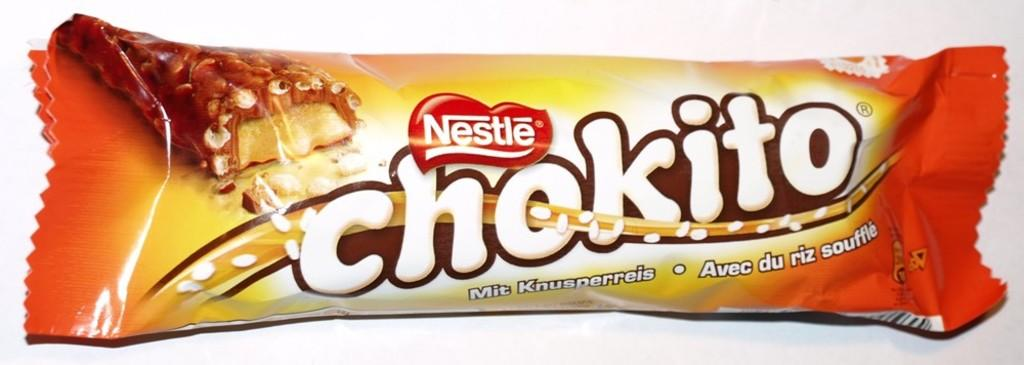What is the main subject of the image? The main subject of the image is a chocolate packet. Where is the chocolate packet located in the image? The chocolate packet is in the center of the image. What can be found on the chocolate packet? There is text on the chocolate packet. Is there a tent visible in the image? No, there is no tent present in the image. Can you see someone kicking a soccer ball in the image? No, there is no soccer ball or person kicking it in the image. 